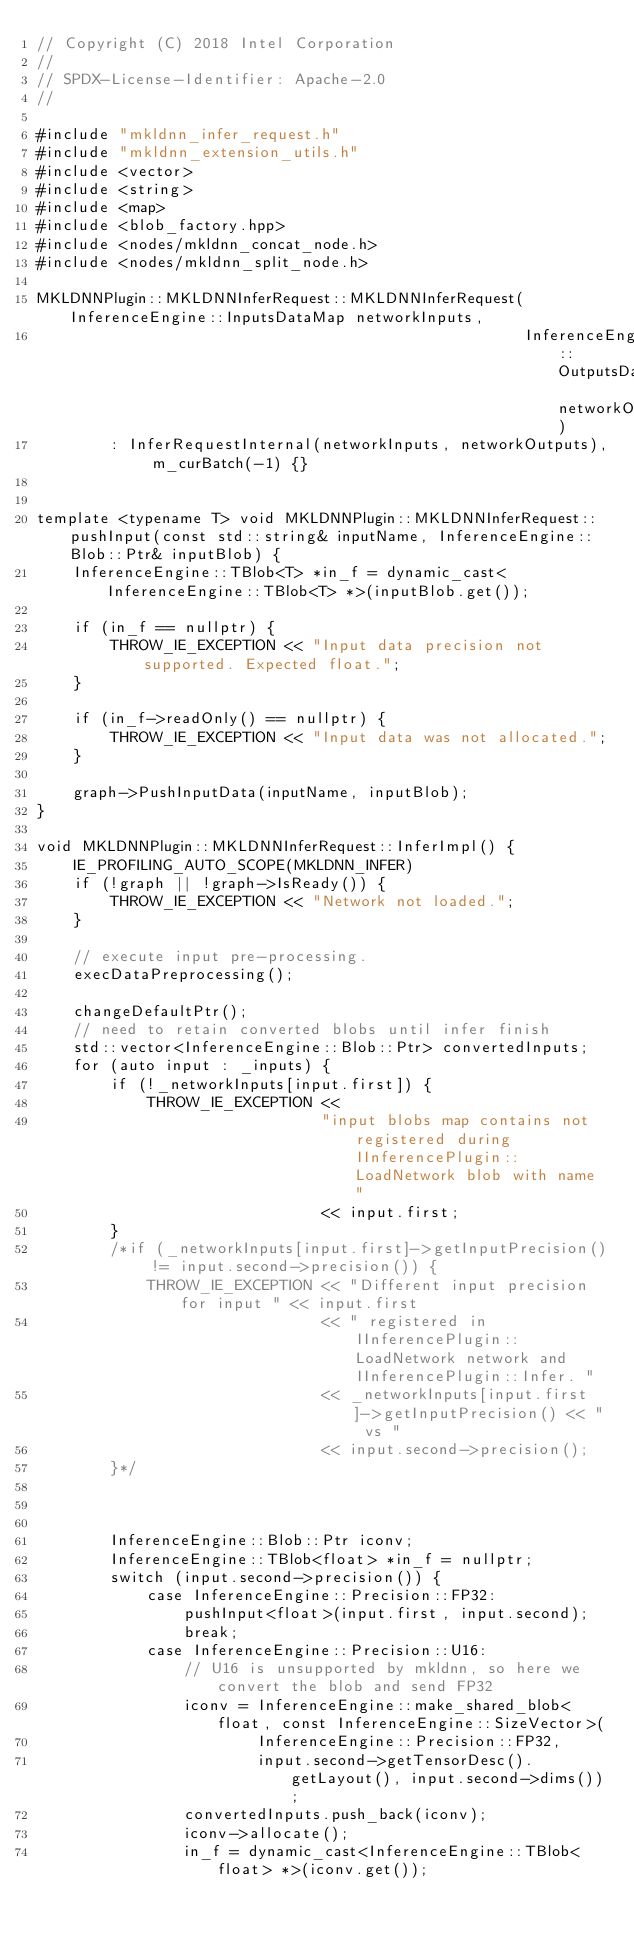Convert code to text. <code><loc_0><loc_0><loc_500><loc_500><_C++_>// Copyright (C) 2018 Intel Corporation
//
// SPDX-License-Identifier: Apache-2.0
//

#include "mkldnn_infer_request.h"
#include "mkldnn_extension_utils.h"
#include <vector>
#include <string>
#include <map>
#include <blob_factory.hpp>
#include <nodes/mkldnn_concat_node.h>
#include <nodes/mkldnn_split_node.h>

MKLDNNPlugin::MKLDNNInferRequest::MKLDNNInferRequest(InferenceEngine::InputsDataMap networkInputs,
                                                     InferenceEngine::OutputsDataMap networkOutputs)
        : InferRequestInternal(networkInputs, networkOutputs), m_curBatch(-1) {}


template <typename T> void MKLDNNPlugin::MKLDNNInferRequest::pushInput(const std::string& inputName, InferenceEngine::Blob::Ptr& inputBlob) {
    InferenceEngine::TBlob<T> *in_f = dynamic_cast<InferenceEngine::TBlob<T> *>(inputBlob.get());

    if (in_f == nullptr) {
        THROW_IE_EXCEPTION << "Input data precision not supported. Expected float.";
    }

    if (in_f->readOnly() == nullptr) {
        THROW_IE_EXCEPTION << "Input data was not allocated.";
    }

    graph->PushInputData(inputName, inputBlob);
}

void MKLDNNPlugin::MKLDNNInferRequest::InferImpl() {
    IE_PROFILING_AUTO_SCOPE(MKLDNN_INFER)
    if (!graph || !graph->IsReady()) {
        THROW_IE_EXCEPTION << "Network not loaded.";
    }

    // execute input pre-processing.
    execDataPreprocessing();

    changeDefaultPtr();
    // need to retain converted blobs until infer finish
    std::vector<InferenceEngine::Blob::Ptr> convertedInputs;
    for (auto input : _inputs) {
        if (!_networkInputs[input.first]) {
            THROW_IE_EXCEPTION <<
                               "input blobs map contains not registered during IInferencePlugin::LoadNetwork blob with name "
                               << input.first;
        }
        /*if (_networkInputs[input.first]->getInputPrecision() != input.second->precision()) {
            THROW_IE_EXCEPTION << "Different input precision for input " << input.first
                               << " registered in IInferencePlugin::LoadNetwork network and IInferencePlugin::Infer. "
                               << _networkInputs[input.first]->getInputPrecision() << " vs "
                               << input.second->precision();
        }*/



        InferenceEngine::Blob::Ptr iconv;
        InferenceEngine::TBlob<float> *in_f = nullptr;
        switch (input.second->precision()) {
            case InferenceEngine::Precision::FP32:
                pushInput<float>(input.first, input.second);
                break;
            case InferenceEngine::Precision::U16:
                // U16 is unsupported by mkldnn, so here we convert the blob and send FP32
                iconv = InferenceEngine::make_shared_blob<float, const InferenceEngine::SizeVector>(
                        InferenceEngine::Precision::FP32,
                        input.second->getTensorDesc().getLayout(), input.second->dims());
                convertedInputs.push_back(iconv);
                iconv->allocate();
                in_f = dynamic_cast<InferenceEngine::TBlob<float> *>(iconv.get());</code> 